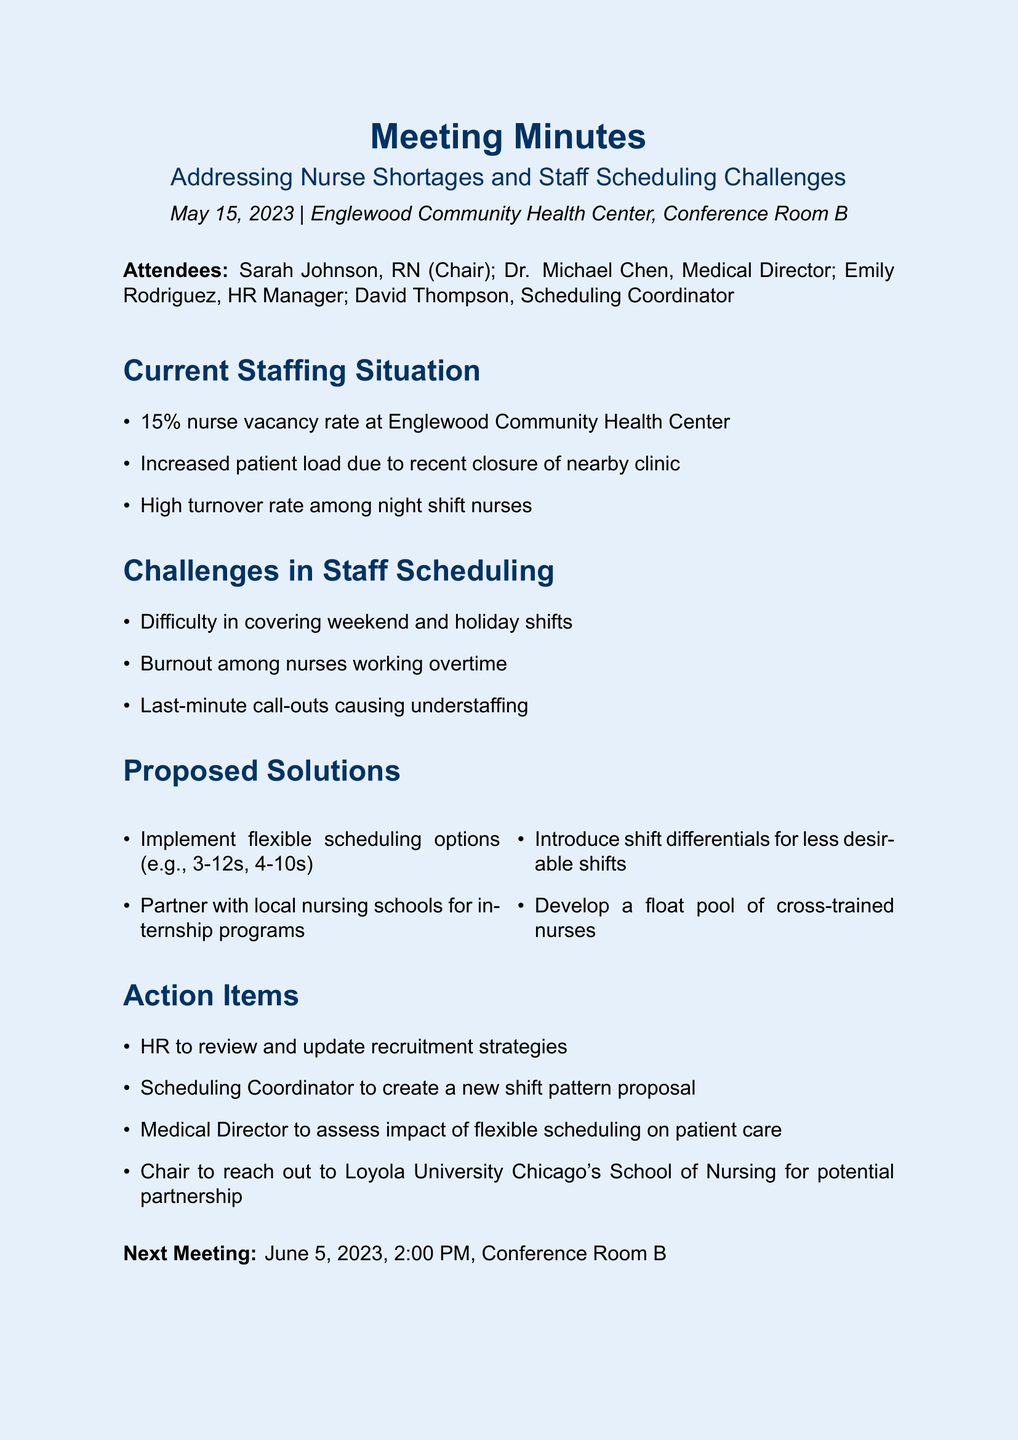What is the nurse vacancy rate? The nurse vacancy rate is mentioned in the current staffing situation section of the document.
Answer: 15% Who is the Chair of the meeting? The meeting chairperson is listed under attendees.
Answer: Sarah Johnson, RN What is one challenge mentioned in staff scheduling? The challenges in staff scheduling section provides specific issues faced by nurses.
Answer: Difficulty in covering weekend and holiday shifts What is one proposed solution to address nurse shortages? The proposed solutions section outlines various measures to tackle the nurse shortages.
Answer: Implement flexible scheduling options When is the next meeting scheduled? The document lists the date and time of the next meeting at the end.
Answer: June 5, 2023, 2:00 PM Which school is the Chair planning to reach out to? The action items section notes a specific partnership the Chair plans to pursue.
Answer: Loyola University Chicago's School of Nursing 